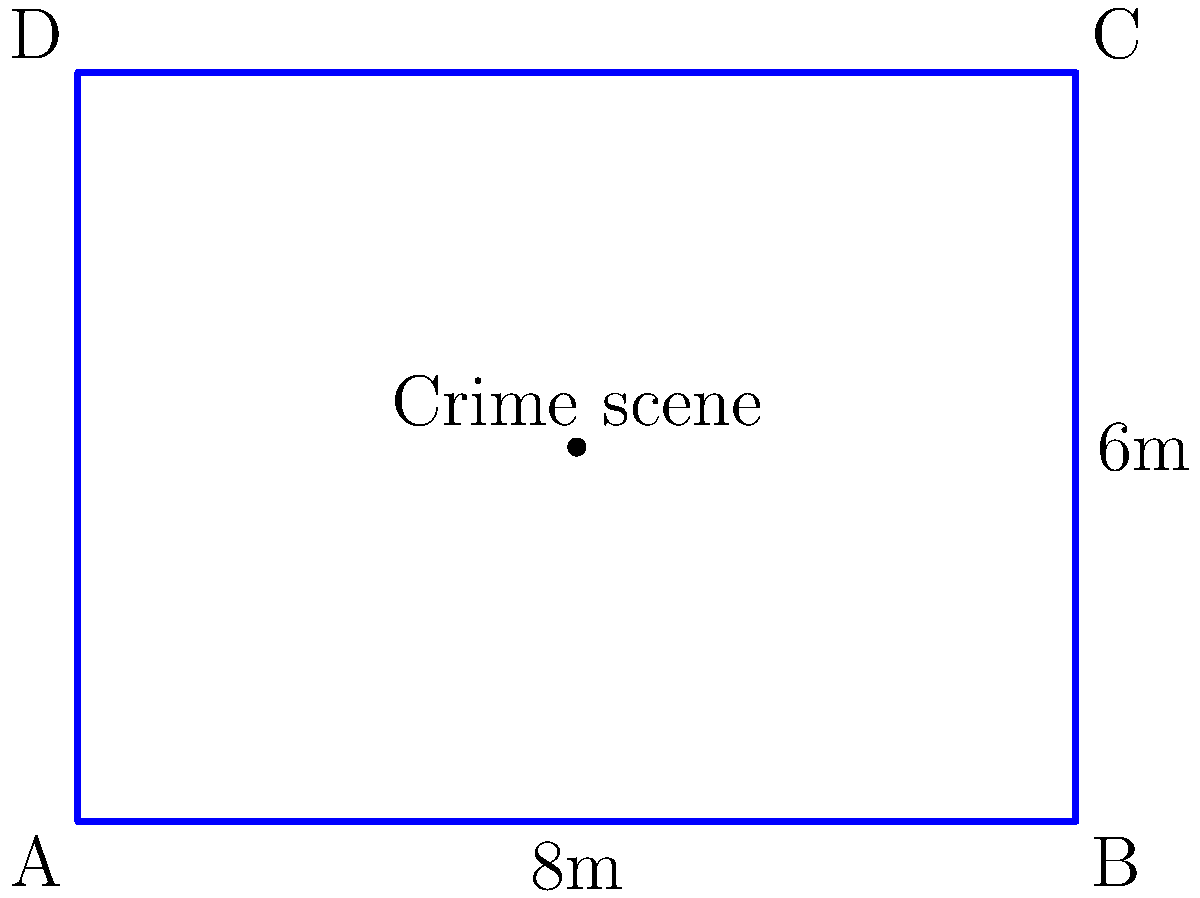In a high-profile murder case, the crime scene is marked by police tape forming a rectangular boundary. The width of the area is 6 meters, and the length is 8 meters. If the cost of specialized forensic tape is $12.50 per meter, what is the total cost of tape needed to completely enclose the crime scene, assuming no overlap or waste? To solve this problem, we need to follow these steps:

1. Calculate the perimeter of the rectangular crime scene:
   - Perimeter = 2 * (length + width)
   - Perimeter = 2 * (8m + 6m)
   - Perimeter = 2 * 14m = 28m

2. Calculate the cost of the tape:
   - Cost per meter = $12.50
   - Total length needed = 28m
   - Total cost = 28m * $12.50/m = $350

Therefore, the total cost of tape needed to enclose the crime scene is $350.

This calculation assumes that the tape is perfectly fitted to the rectangular boundary without any overlap or waste. In practice, there might be some additional tape used for securing corners or accounting for slight irregularities in the terrain.

As a criminal defense attorney, you might argue that the precise measurement and enclosure of the crime scene is crucial for preserving evidence integrity and preventing contamination. The use of specialized forensic tape, while costly, demonstrates the prosecution's commitment to maintaining a secure crime scene, which could be leveraged in your defense strategy depending on the specifics of the case.
Answer: $350 